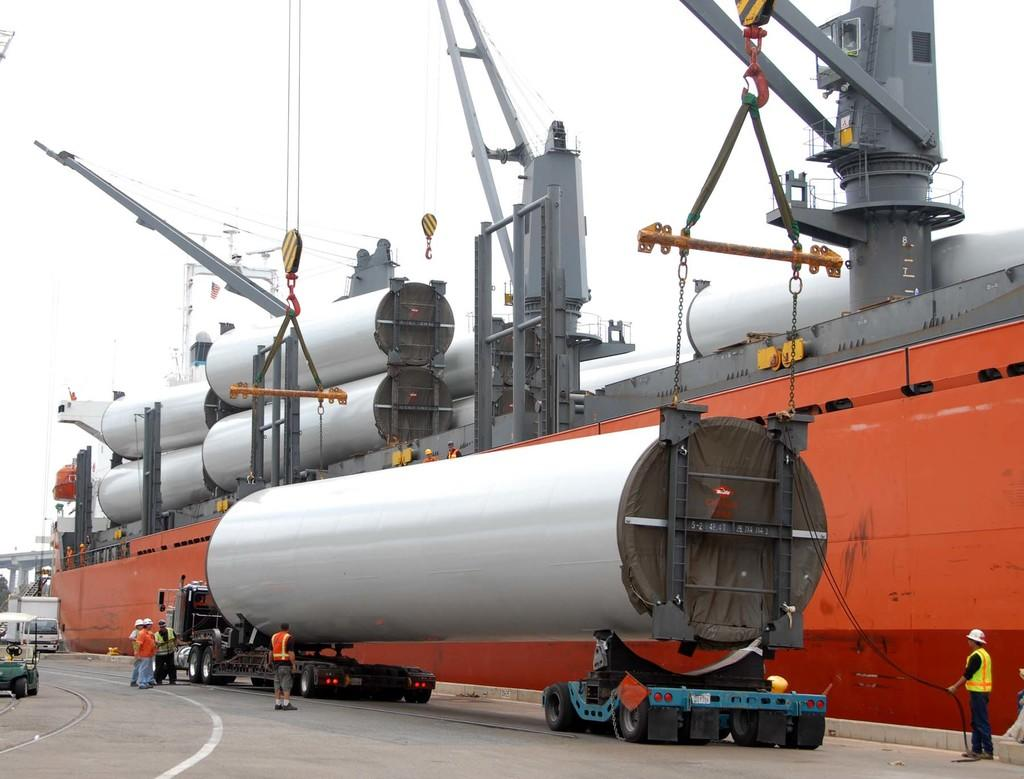What are the people in the image wearing on their heads? The people in the image are wearing helmets. What type of vehicles are present in the image? There are tankers in the image. What objects are used to secure or hold something in the image? Chains are present in the image. What can be used to hang or store items in the image? Hangers are visible in the image. What is visible on the road in the image? There are vehicles on the road in the image. What is visible at the top of the image? The sky is visible at the top of the image. What type of curtain is hanging in the image? There is no curtain present in the image. Who is the representative wearing a crown in the image? There is no representative or crown present in the image. 